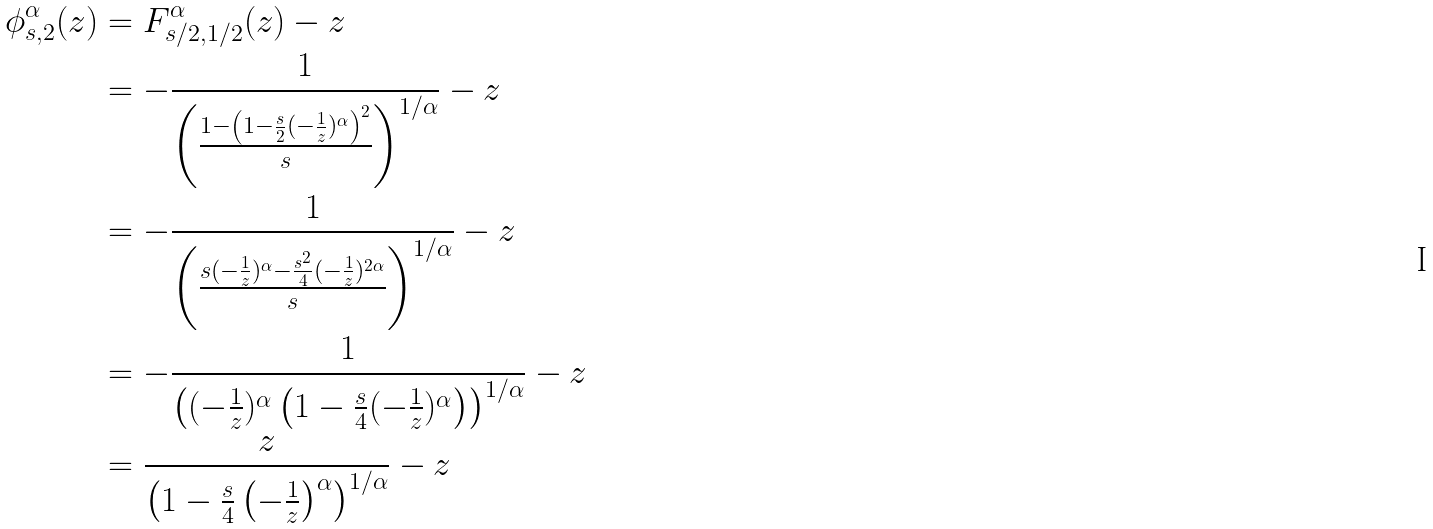Convert formula to latex. <formula><loc_0><loc_0><loc_500><loc_500>\phi ^ { \alpha } _ { s , 2 } ( z ) & = F ^ { \alpha } _ { s / 2 , 1 / 2 } ( z ) - z \\ & = - \frac { 1 } { \left ( \frac { 1 - \left ( 1 - \frac { s } { 2 } ( - \frac { 1 } { z } ) ^ { \alpha } \right ) ^ { 2 } } { s } \right ) ^ { 1 / \alpha } } - z \\ & = - \frac { 1 } { \left ( \frac { s ( - \frac { 1 } { z } ) ^ { \alpha } - \frac { s ^ { 2 } } { 4 } ( - \frac { 1 } { z } ) ^ { 2 \alpha } } { s } \right ) ^ { 1 / \alpha } } - z \\ & = - \frac { 1 } { \left ( ( - \frac { 1 } { z } ) ^ { \alpha } \left ( 1 - \frac { s } { 4 } ( - \frac { 1 } { z } ) ^ { \alpha } \right ) \right ) ^ { 1 / \alpha } } - z \\ & = \frac { z } { \left ( 1 - \frac { s } { 4 } \left ( - \frac { 1 } { z } \right ) ^ { \alpha } \right ) ^ { 1 / \alpha } } - z</formula> 